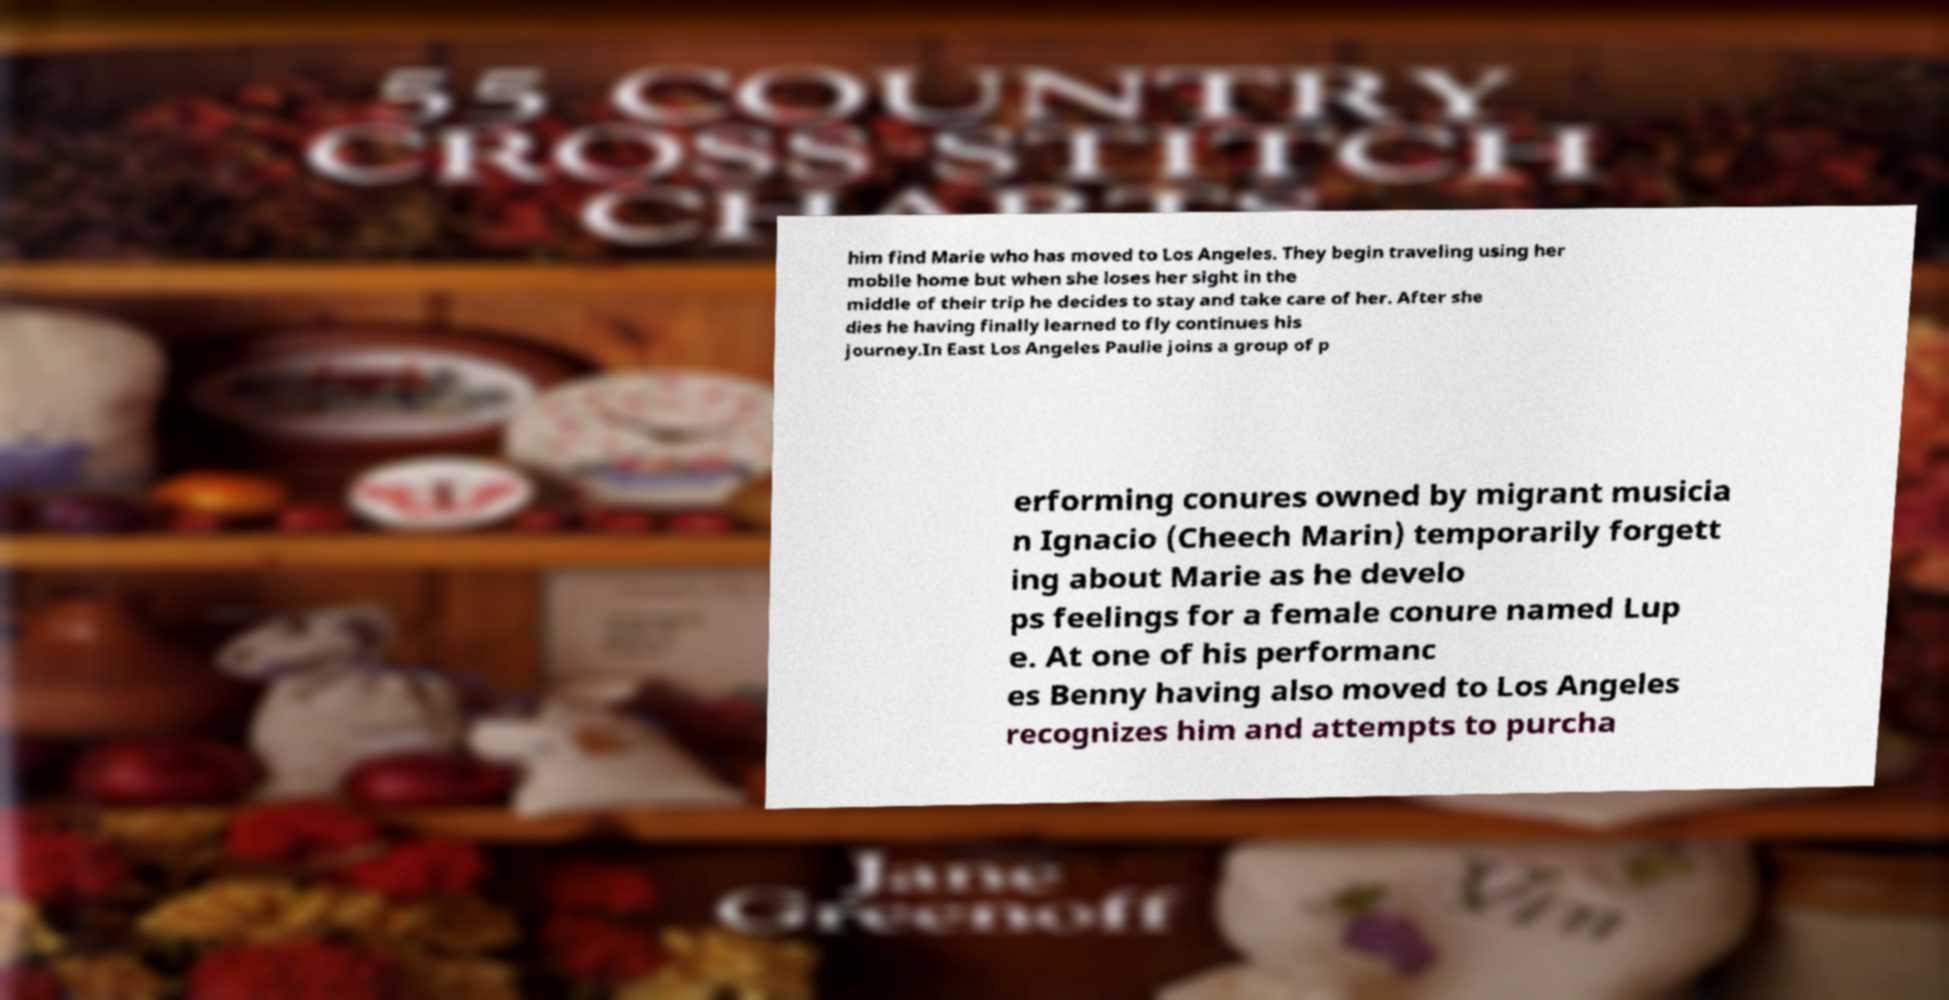Could you extract and type out the text from this image? him find Marie who has moved to Los Angeles. They begin traveling using her mobile home but when she loses her sight in the middle of their trip he decides to stay and take care of her. After she dies he having finally learned to fly continues his journey.In East Los Angeles Paulie joins a group of p erforming conures owned by migrant musicia n Ignacio (Cheech Marin) temporarily forgett ing about Marie as he develo ps feelings for a female conure named Lup e. At one of his performanc es Benny having also moved to Los Angeles recognizes him and attempts to purcha 